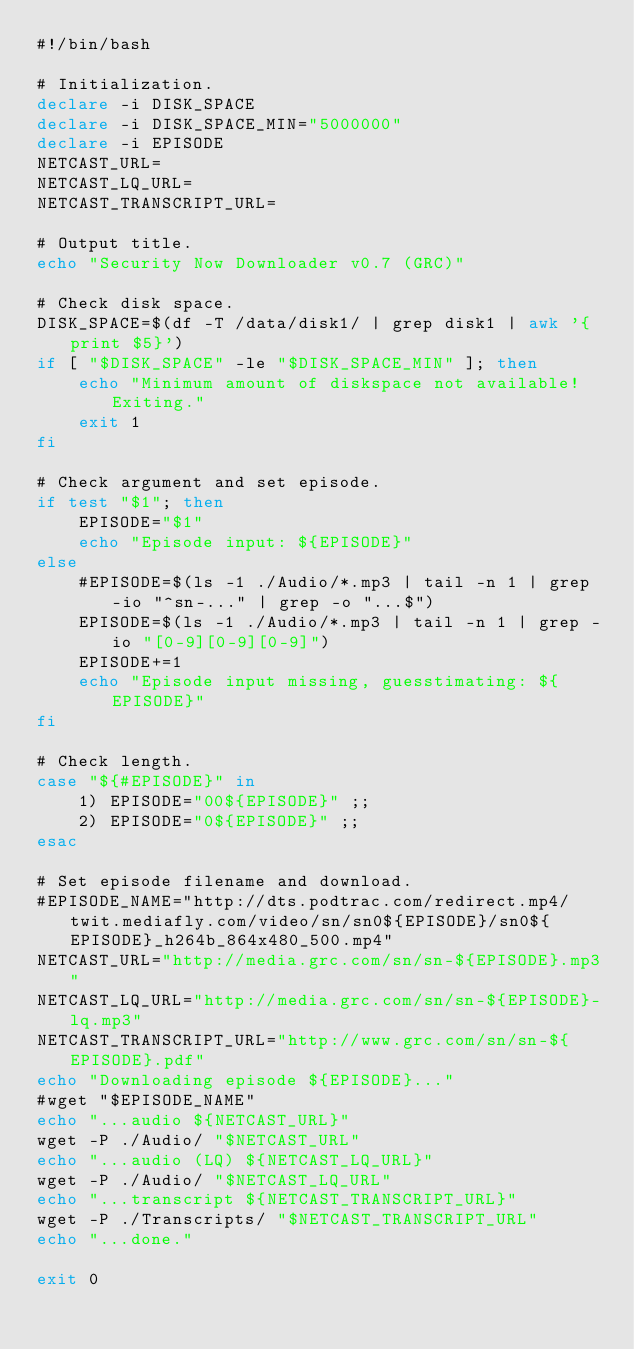Convert code to text. <code><loc_0><loc_0><loc_500><loc_500><_Bash_>#!/bin/bash

# Initialization.
declare -i DISK_SPACE
declare -i DISK_SPACE_MIN="5000000"
declare -i EPISODE
NETCAST_URL=
NETCAST_LQ_URL=
NETCAST_TRANSCRIPT_URL=

# Output title.
echo "Security Now Downloader v0.7 (GRC)"

# Check disk space.
DISK_SPACE=$(df -T /data/disk1/ | grep disk1 | awk '{print $5}')
if [ "$DISK_SPACE" -le "$DISK_SPACE_MIN" ]; then
    echo "Minimum amount of diskspace not available! Exiting."
    exit 1
fi

# Check argument and set episode.
if test "$1"; then
    EPISODE="$1"
    echo "Episode input: ${EPISODE}"
else
    #EPISODE=$(ls -1 ./Audio/*.mp3 | tail -n 1 | grep -io "^sn-..." | grep -o "...$")
    EPISODE=$(ls -1 ./Audio/*.mp3 | tail -n 1 | grep -io "[0-9][0-9][0-9]")
    EPISODE+=1
    echo "Episode input missing, guesstimating: ${EPISODE}"
fi

# Check length.
case "${#EPISODE}" in
    1) EPISODE="00${EPISODE}" ;;
    2) EPISODE="0${EPISODE}" ;;
esac

# Set episode filename and download.
#EPISODE_NAME="http://dts.podtrac.com/redirect.mp4/twit.mediafly.com/video/sn/sn0${EPISODE}/sn0${EPISODE}_h264b_864x480_500.mp4"
NETCAST_URL="http://media.grc.com/sn/sn-${EPISODE}.mp3"
NETCAST_LQ_URL="http://media.grc.com/sn/sn-${EPISODE}-lq.mp3"
NETCAST_TRANSCRIPT_URL="http://www.grc.com/sn/sn-${EPISODE}.pdf"
echo "Downloading episode ${EPISODE}..."
#wget "$EPISODE_NAME"
echo "...audio ${NETCAST_URL}"
wget -P ./Audio/ "$NETCAST_URL"
echo "...audio (LQ) ${NETCAST_LQ_URL}"
wget -P ./Audio/ "$NETCAST_LQ_URL"
echo "...transcript ${NETCAST_TRANSCRIPT_URL}"
wget -P ./Transcripts/ "$NETCAST_TRANSCRIPT_URL"
echo "...done."

exit 0
</code> 